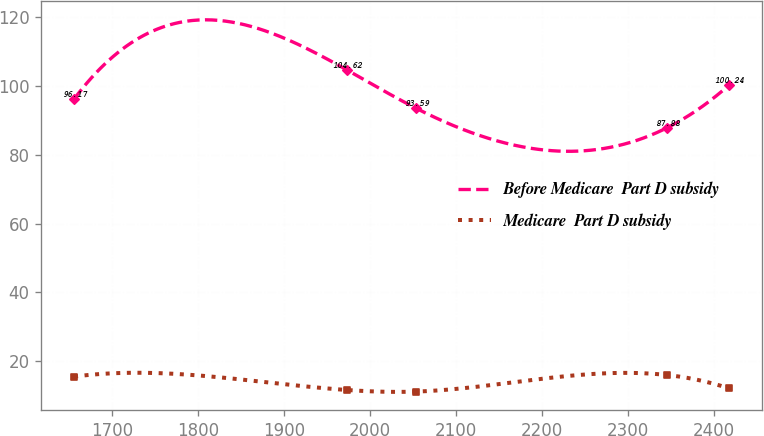<chart> <loc_0><loc_0><loc_500><loc_500><line_chart><ecel><fcel>Before Medicare  Part D subsidy<fcel>Medicare  Part D subsidy<nl><fcel>1656<fcel>96.17<fcel>15.56<nl><fcel>1973.46<fcel>104.62<fcel>11.67<nl><fcel>2053.12<fcel>93.59<fcel>11.21<nl><fcel>2345.74<fcel>87.88<fcel>16.02<nl><fcel>2417.52<fcel>100.24<fcel>12.13<nl></chart> 